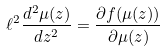Convert formula to latex. <formula><loc_0><loc_0><loc_500><loc_500>\ell ^ { 2 } \frac { d ^ { 2 } \mu ( z ) } { d z ^ { 2 } } = \frac { \partial f ( \mu ( z ) ) } { \partial \mu ( z ) }</formula> 